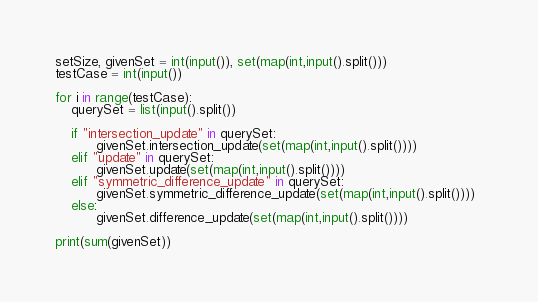Convert code to text. <code><loc_0><loc_0><loc_500><loc_500><_Python_>
setSize, givenSet = int(input()), set(map(int,input().split()))
testCase = int(input())

for i in range(testCase):
    querySet = list(input().split())
    
    if "intersection_update" in querySet:
          givenSet.intersection_update(set(map(int,input().split())))
    elif "update" in querySet:
          givenSet.update(set(map(int,input().split())))
    elif "symmetric_difference_update" in querySet:
          givenSet.symmetric_difference_update(set(map(int,input().split())))  
    else:   
          givenSet.difference_update(set(map(int,input().split())))

print(sum(givenSet))

</code> 